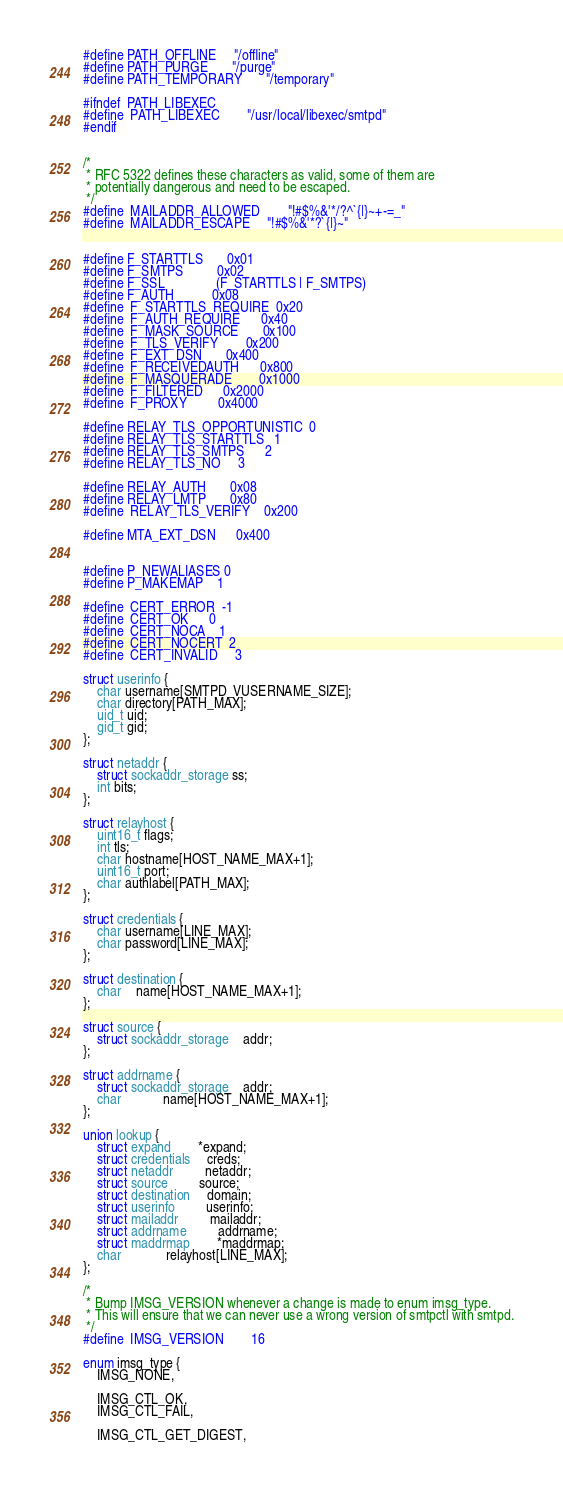Convert code to text. <code><loc_0><loc_0><loc_500><loc_500><_C_>
#define PATH_OFFLINE		"/offline"
#define PATH_PURGE		"/purge"
#define PATH_TEMPORARY		"/temporary"

#ifndef	PATH_LIBEXEC
#define	PATH_LIBEXEC		"/usr/local/libexec/smtpd"
#endif


/*
 * RFC 5322 defines these characters as valid, some of them are
 * potentially dangerous and need to be escaped.
 */
#define	MAILADDR_ALLOWED       	"!#$%&'*/?^`{|}~+-=_"
#define	MAILADDR_ESCAPE		"!#$%&'*?`{|}~"


#define F_STARTTLS		0x01
#define F_SMTPS			0x02
#define F_SSL		       (F_STARTTLS | F_SMTPS)
#define F_AUTH			0x08
#define	F_STARTTLS_REQUIRE	0x20
#define	F_AUTH_REQUIRE		0x40
#define	F_MASK_SOURCE		0x100
#define	F_TLS_VERIFY		0x200
#define	F_EXT_DSN		0x400
#define	F_RECEIVEDAUTH		0x800
#define	F_MASQUERADE		0x1000
#define	F_FILTERED		0x2000
#define	F_PROXY			0x4000

#define RELAY_TLS_OPPORTUNISTIC	0
#define RELAY_TLS_STARTTLS	1
#define RELAY_TLS_SMTPS		2
#define RELAY_TLS_NO		3

#define RELAY_AUTH		0x08
#define RELAY_LMTP		0x80
#define	RELAY_TLS_VERIFY	0x200

#define MTA_EXT_DSN		0x400


#define P_NEWALIASES	0
#define P_MAKEMAP	1

#define	CERT_ERROR	-1
#define	CERT_OK		 0
#define	CERT_NOCA	 1
#define	CERT_NOCERT	 2
#define	CERT_INVALID	 3

struct userinfo {
	char username[SMTPD_VUSERNAME_SIZE];
	char directory[PATH_MAX];
	uid_t uid;
	gid_t gid;
};

struct netaddr {
	struct sockaddr_storage ss;
	int bits;
};

struct relayhost {
	uint16_t flags;
	int tls;
	char hostname[HOST_NAME_MAX+1];
	uint16_t port;
	char authlabel[PATH_MAX];
};

struct credentials {
	char username[LINE_MAX];
	char password[LINE_MAX];
};

struct destination {
	char	name[HOST_NAME_MAX+1];
};

struct source {
	struct sockaddr_storage	addr;
};

struct addrname {
	struct sockaddr_storage	addr;
	char			name[HOST_NAME_MAX+1];
};

union lookup {
	struct expand		*expand;
	struct credentials	 creds;
	struct netaddr		 netaddr;
	struct source		 source;
	struct destination	 domain;
	struct userinfo		 userinfo;
	struct mailaddr		 mailaddr;
	struct addrname		 addrname;
	struct maddrmap		*maddrmap;
	char			 relayhost[LINE_MAX];
};

/*
 * Bump IMSG_VERSION whenever a change is made to enum imsg_type.
 * This will ensure that we can never use a wrong version of smtpctl with smtpd.
 */
#define	IMSG_VERSION		16

enum imsg_type {
	IMSG_NONE,

	IMSG_CTL_OK,
	IMSG_CTL_FAIL,

	IMSG_CTL_GET_DIGEST,</code> 